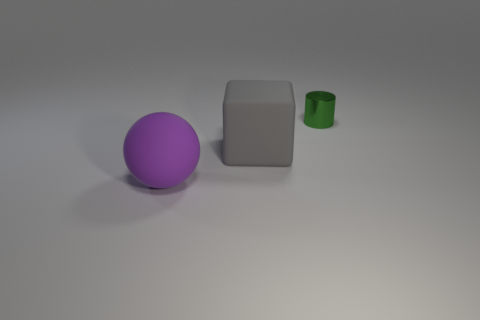Add 2 cylinders. How many objects exist? 5 Subtract all cylinders. How many objects are left? 2 Subtract all matte spheres. Subtract all tiny cylinders. How many objects are left? 1 Add 3 cylinders. How many cylinders are left? 4 Add 3 blue matte cylinders. How many blue matte cylinders exist? 3 Subtract 0 red cylinders. How many objects are left? 3 